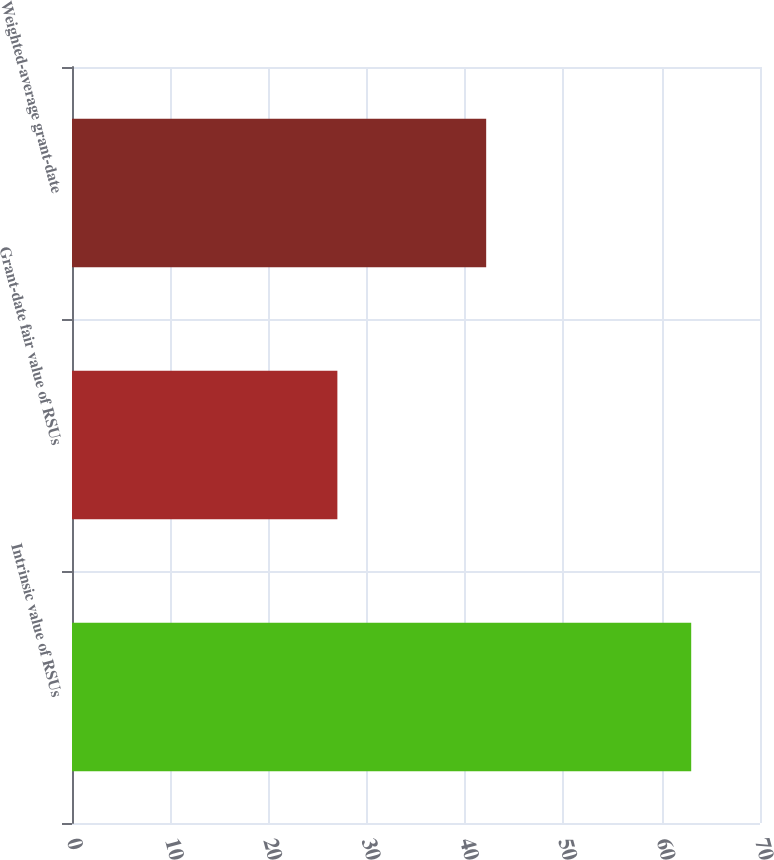Convert chart. <chart><loc_0><loc_0><loc_500><loc_500><bar_chart><fcel>Intrinsic value of RSUs<fcel>Grant-date fair value of RSUs<fcel>Weighted-average grant-date<nl><fcel>63<fcel>27<fcel>42.14<nl></chart> 